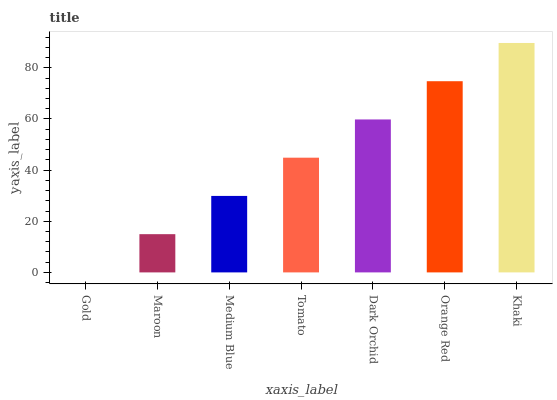Is Gold the minimum?
Answer yes or no. Yes. Is Khaki the maximum?
Answer yes or no. Yes. Is Maroon the minimum?
Answer yes or no. No. Is Maroon the maximum?
Answer yes or no. No. Is Maroon greater than Gold?
Answer yes or no. Yes. Is Gold less than Maroon?
Answer yes or no. Yes. Is Gold greater than Maroon?
Answer yes or no. No. Is Maroon less than Gold?
Answer yes or no. No. Is Tomato the high median?
Answer yes or no. Yes. Is Tomato the low median?
Answer yes or no. Yes. Is Medium Blue the high median?
Answer yes or no. No. Is Gold the low median?
Answer yes or no. No. 